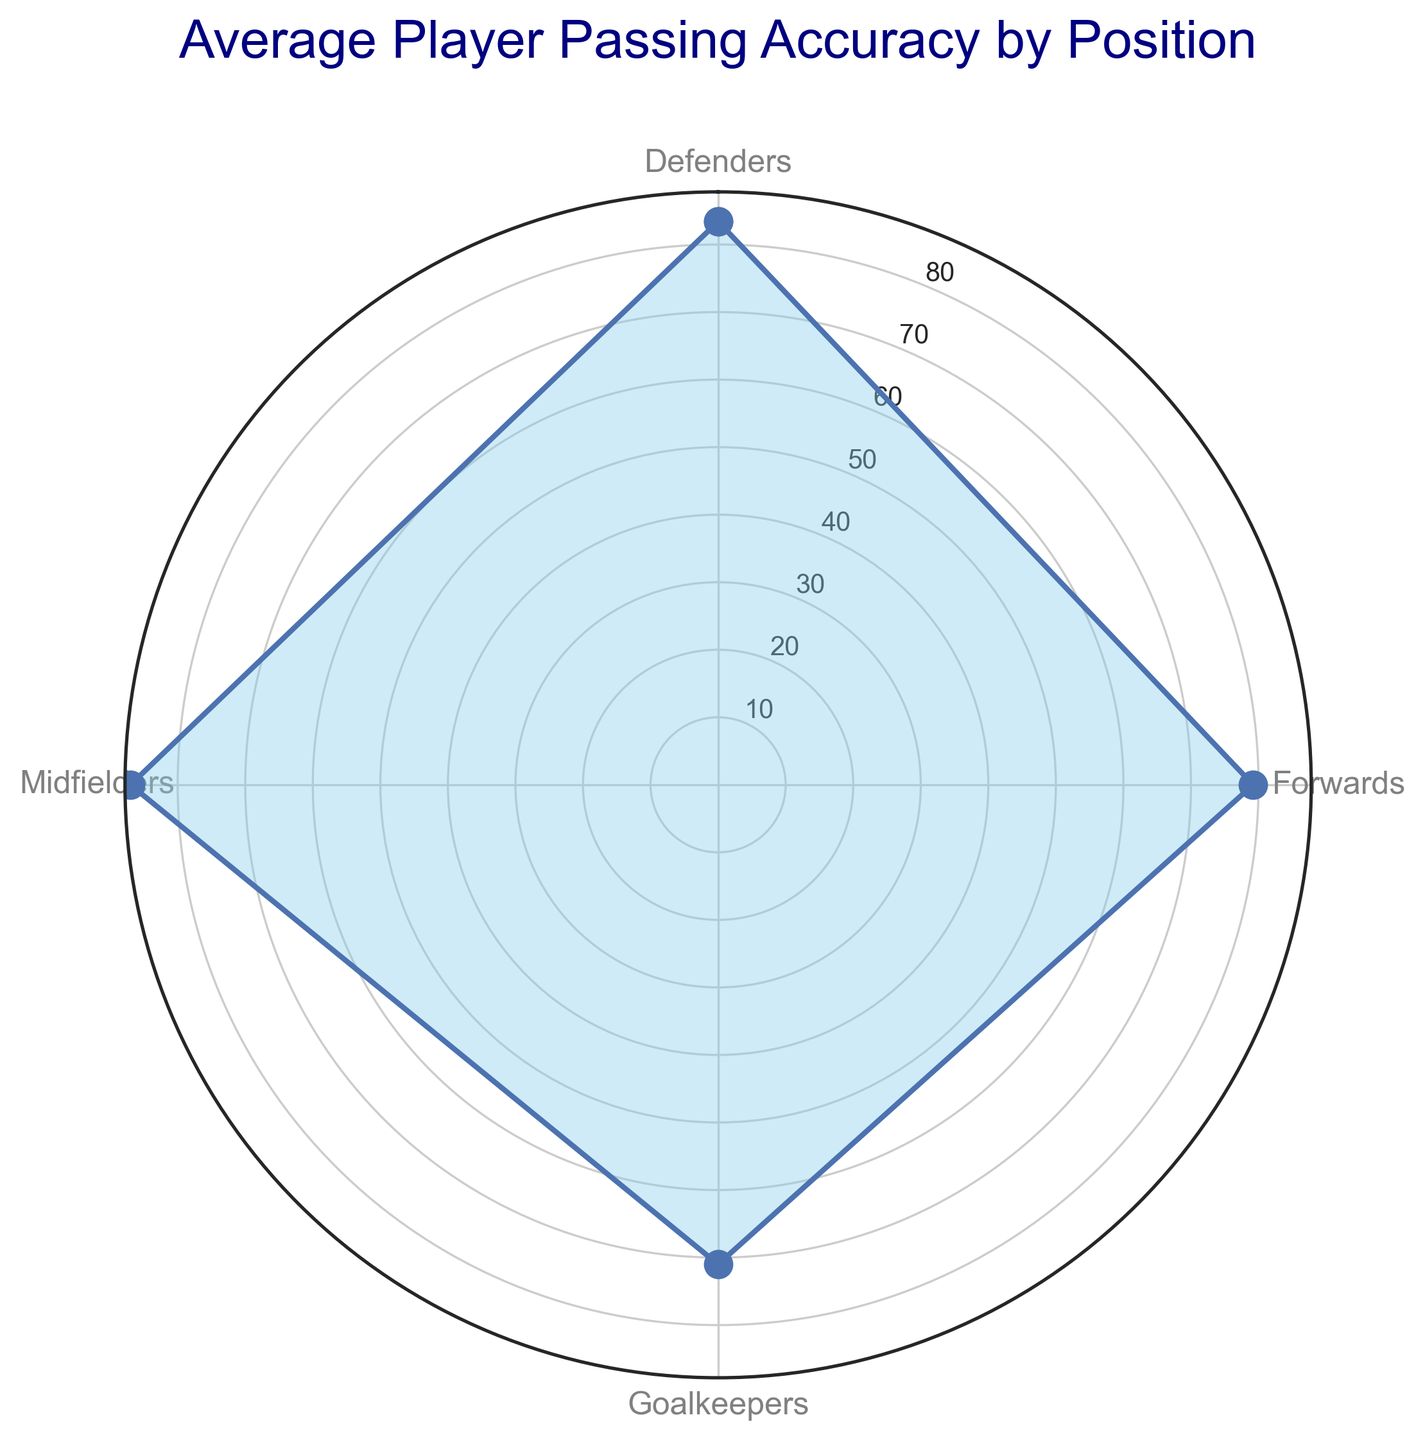What position has the highest average passing accuracy? Based on the rose chart, the average passing accuracy for each position is represented, and we can see which segment stretches out furthest indicating the highest value. The Midfielders' segment extends furthest, showing they have the highest average passing accuracy.
Answer: Midfielders What is the difference in average passing accuracy between Defenders and Goalkeepers? The chart shows that Defenders have an average passing accuracy of about 83.4. Goalkeepers have an average passing accuracy of around 71.4. The difference is calculated as 83.4 - 71.4.
Answer: 12 Which two positions have the closest average passing accuracy values? Based on the rose chart, we observe that Defenders and Forwards have segments of similar length, both close to around 83 and 79 respectively.
Answer: Forwards and Defenders How does the average passing accuracy of Forwards compare to that of Midfielders? From the rose chart, it can be seen that the average passing accuracy of Forwards (79.2) is less than that of Midfielders (87.0).
Answer: Forwards is less than Midfielders Which position has the lowest average passing accuracy and what is that value? The smallest segment on the chart corresponds to the Goalkeepers, indicating they have the lowest average passing accuracy.
Answer: Goalkeepers, 71.4 What is the average passing accuracy of all positions combined? Calculating the mean of the average passing accuracy values for all positions: (79.2 + 87.0 + 83.4 + 71.4) / 4 = 80.25
Answer: 80.25 